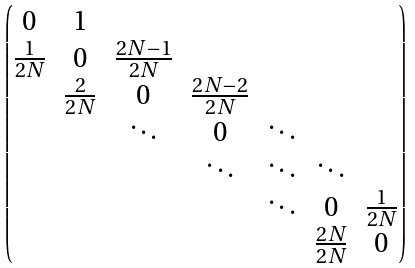<formula> <loc_0><loc_0><loc_500><loc_500>\begin{pmatrix} 0 & 1 \\ \frac { 1 } { 2 N } & 0 & \frac { 2 N - 1 } { 2 N } \\ & \frac { 2 } { 2 N } & 0 & \frac { 2 N - 2 } { 2 N } \\ & & \ddots & 0 & \ddots \\ & & & \ddots & \ddots & \ddots \\ & & & & \ddots & 0 & \frac { 1 } { 2 N } \\ & & & & & \frac { 2 N } { 2 N } & 0 \end{pmatrix}</formula> 